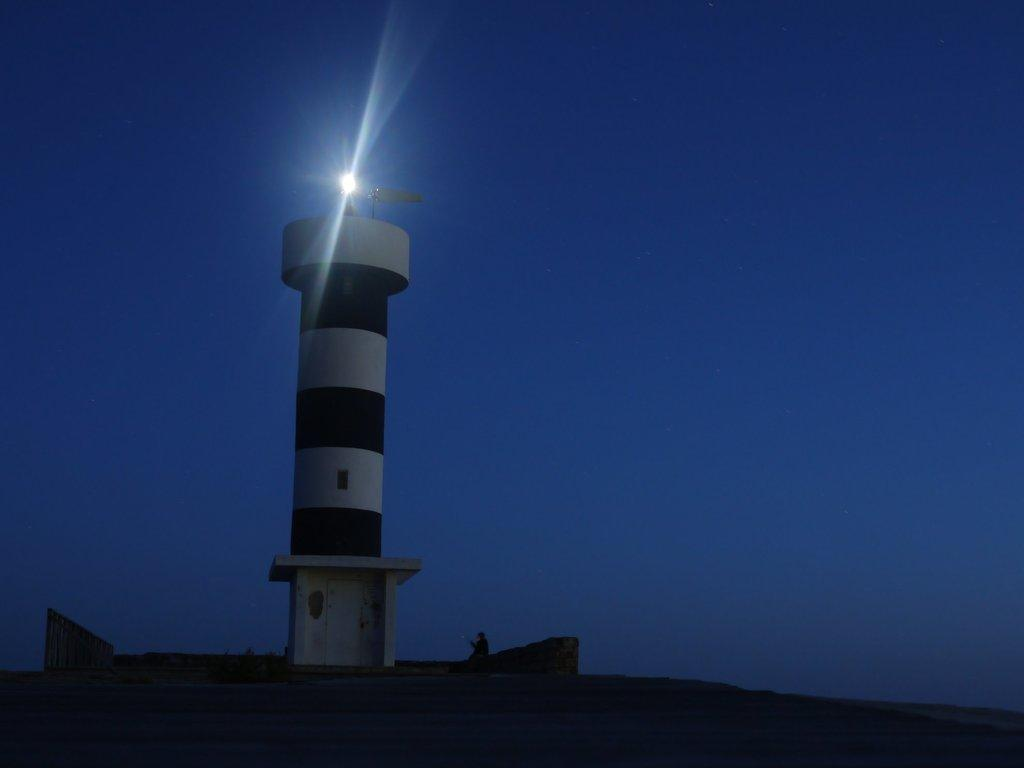What is the main structure in the middle of the image? There is a lighthouse in the middle of the image. What is located above the lighthouse? There is a light above the lighthouse. Can you describe the person in the image? It appears that there is a person sitting in front of the lighthouse on a rock. What can be seen above the lighthouse? The sky is visible above the lighthouse. How many cars are parked near the lighthouse in the image? There are no cars visible in the image; it features a lighthouse, a light, a person sitting on a rock, and the sky. What class is the person attending while sitting in front of the lighthouse? There is no indication in the image that the person is attending a class or any educational activity. 